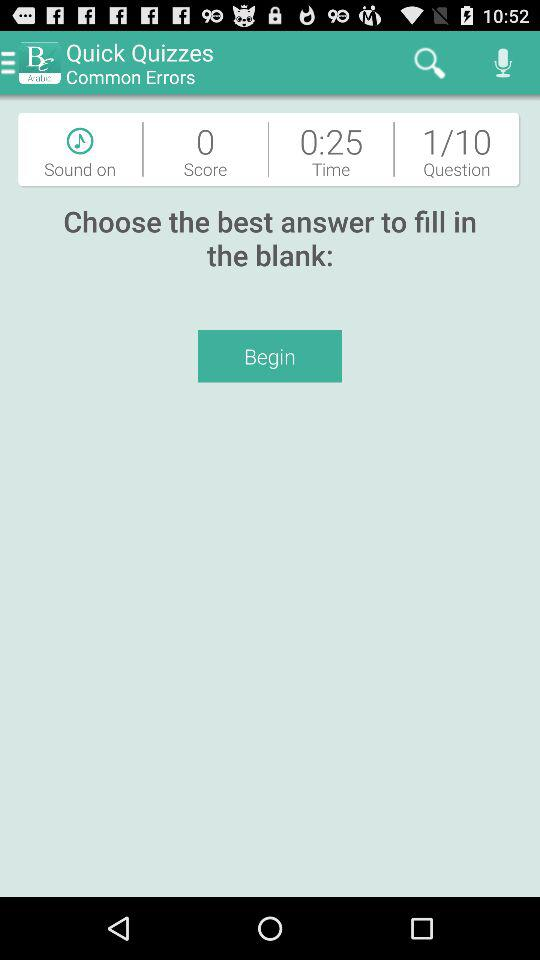What is the remaining time? The remaining time is 25 seconds. 